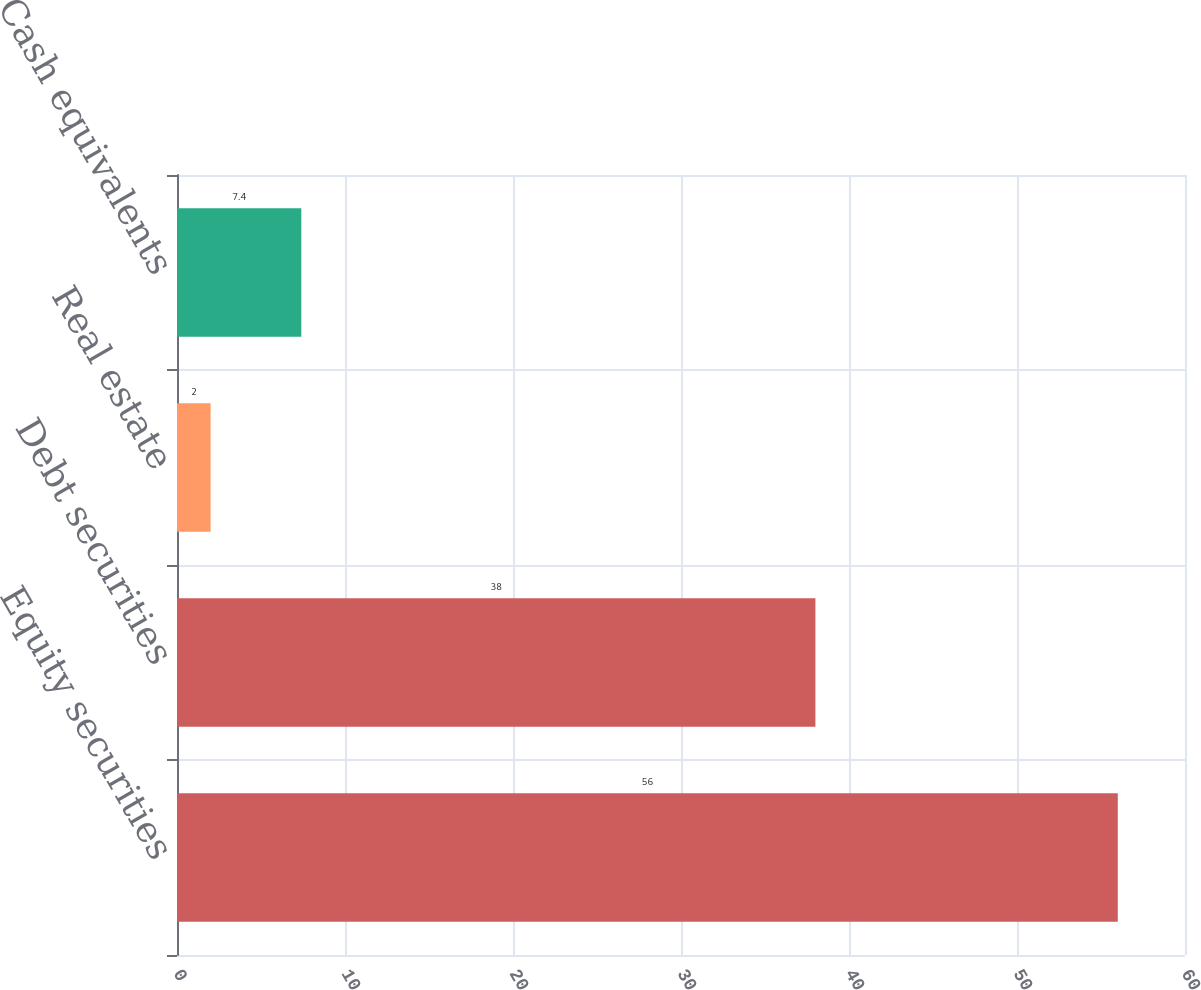<chart> <loc_0><loc_0><loc_500><loc_500><bar_chart><fcel>Equity securities<fcel>Debt securities<fcel>Real estate<fcel>Cash equivalents<nl><fcel>56<fcel>38<fcel>2<fcel>7.4<nl></chart> 